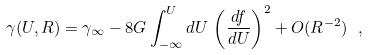Convert formula to latex. <formula><loc_0><loc_0><loc_500><loc_500>\gamma ( U , R ) = \gamma _ { \infty } - 8 G \int _ { - \infty } ^ { U } d U \, \left ( \frac { d f } { d U } \right ) ^ { 2 } + O ( R ^ { - 2 } ) \ ,</formula> 